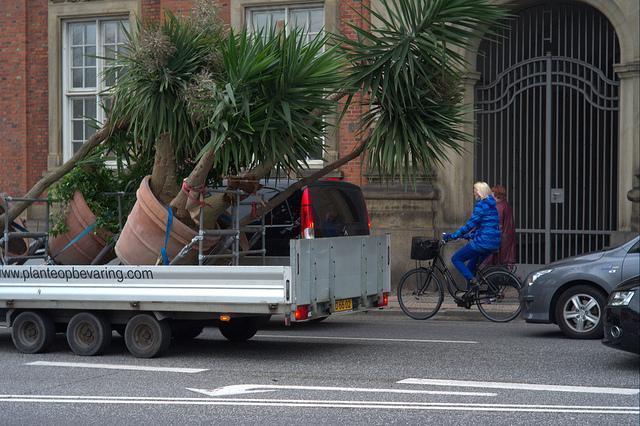How many potted plants can you see?
Give a very brief answer. 3. How many cars can you see?
Give a very brief answer. 2. How many giraffes are inside the building?
Give a very brief answer. 0. 